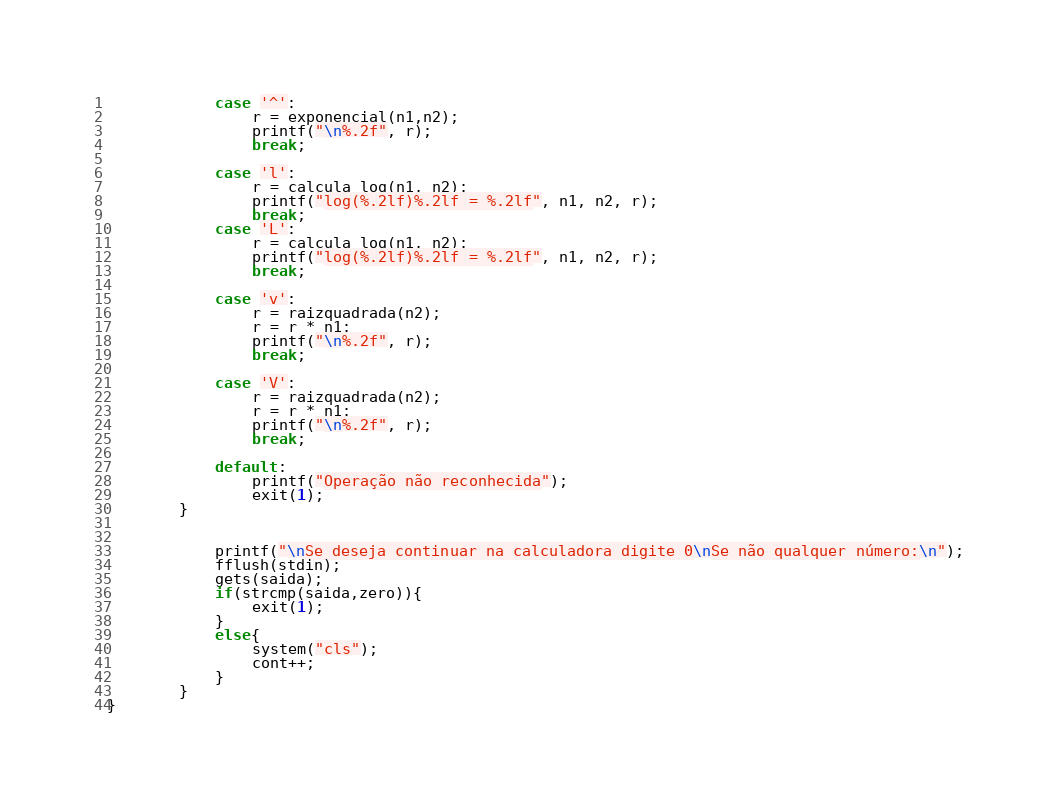<code> <loc_0><loc_0><loc_500><loc_500><_C++_>    		case '^':
    			r = exponencial(n1,n2);
    			printf("\n%.2f", r);
    			break;
    		
   		 	case 'l':
    			r = calcula_log(n1, n2);
    			printf("log(%.2lf)%.2lf = %.2lf", n1, n2, r);
    			break;
    		case 'L':
    			r = calcula_log(n1, n2);
    			printf("log(%.2lf)%.2lf = %.2lf", n1, n2, r);
    			break;
    		
	    	case 'v':
    			r = raizquadrada(n2);
    			r = r * n1;
    			printf("\n%.2f", r);
    			break;
    			
    		case 'V':
    			r = raizquadrada(n2);
    			r = r * n1;
    			printf("\n%.2f", r);
    			break;
    		
    		default:
    			printf("Operação não reconhecida");
    			exit(1);
    	}	
		
	
			printf("\nSe deseja continuar na calculadora digite 0\nSe não qualquer número:\n");
    		fflush(stdin);
			gets(saida);
			if(strcmp(saida,zero)){
    			exit(1);
			}
			else{
    			system("cls");
    			cont++;
    		}
    	}
}


</code> 